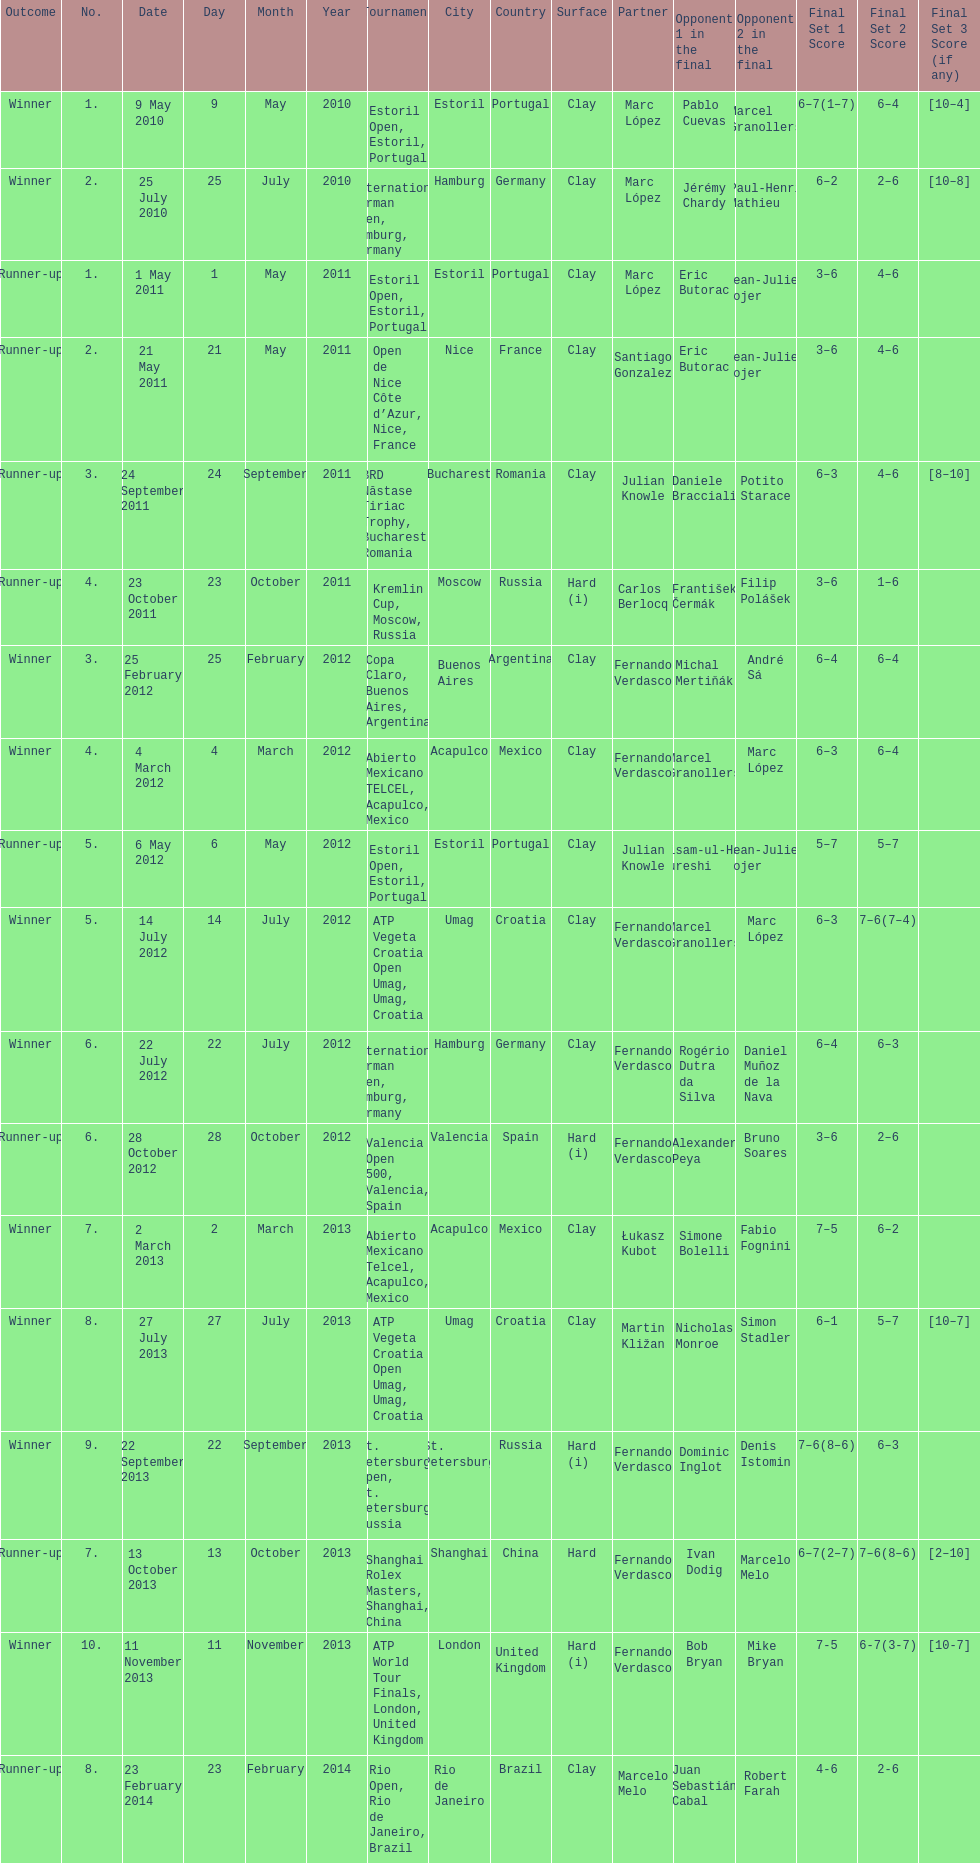How many tournaments has this player won in his career so far? 10. 